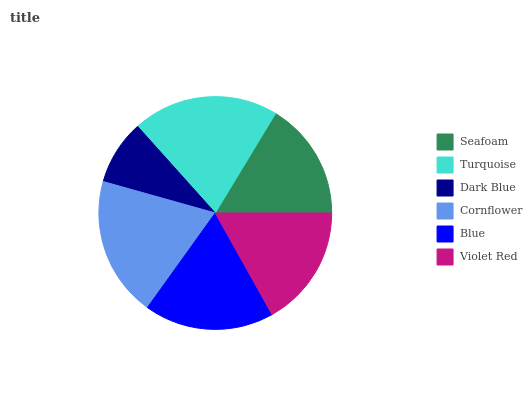Is Dark Blue the minimum?
Answer yes or no. Yes. Is Turquoise the maximum?
Answer yes or no. Yes. Is Turquoise the minimum?
Answer yes or no. No. Is Dark Blue the maximum?
Answer yes or no. No. Is Turquoise greater than Dark Blue?
Answer yes or no. Yes. Is Dark Blue less than Turquoise?
Answer yes or no. Yes. Is Dark Blue greater than Turquoise?
Answer yes or no. No. Is Turquoise less than Dark Blue?
Answer yes or no. No. Is Blue the high median?
Answer yes or no. Yes. Is Violet Red the low median?
Answer yes or no. Yes. Is Dark Blue the high median?
Answer yes or no. No. Is Cornflower the low median?
Answer yes or no. No. 